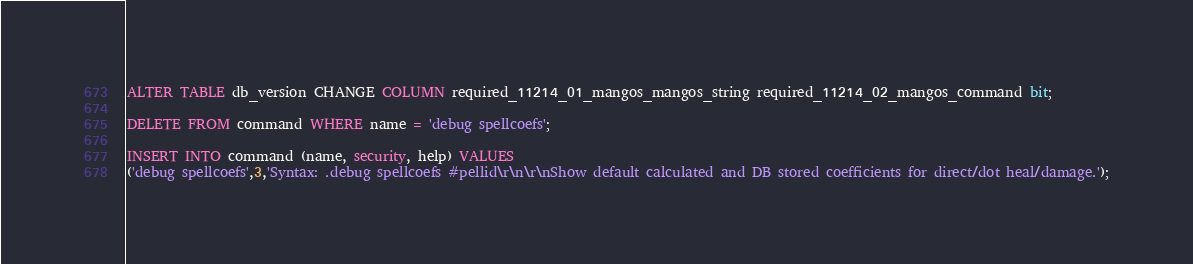<code> <loc_0><loc_0><loc_500><loc_500><_SQL_>ALTER TABLE db_version CHANGE COLUMN required_11214_01_mangos_mangos_string required_11214_02_mangos_command bit;

DELETE FROM command WHERE name = 'debug spellcoefs';

INSERT INTO command (name, security, help) VALUES
('debug spellcoefs',3,'Syntax: .debug spellcoefs #pellid\r\n\r\nShow default calculated and DB stored coefficients for direct/dot heal/damage.');
</code> 